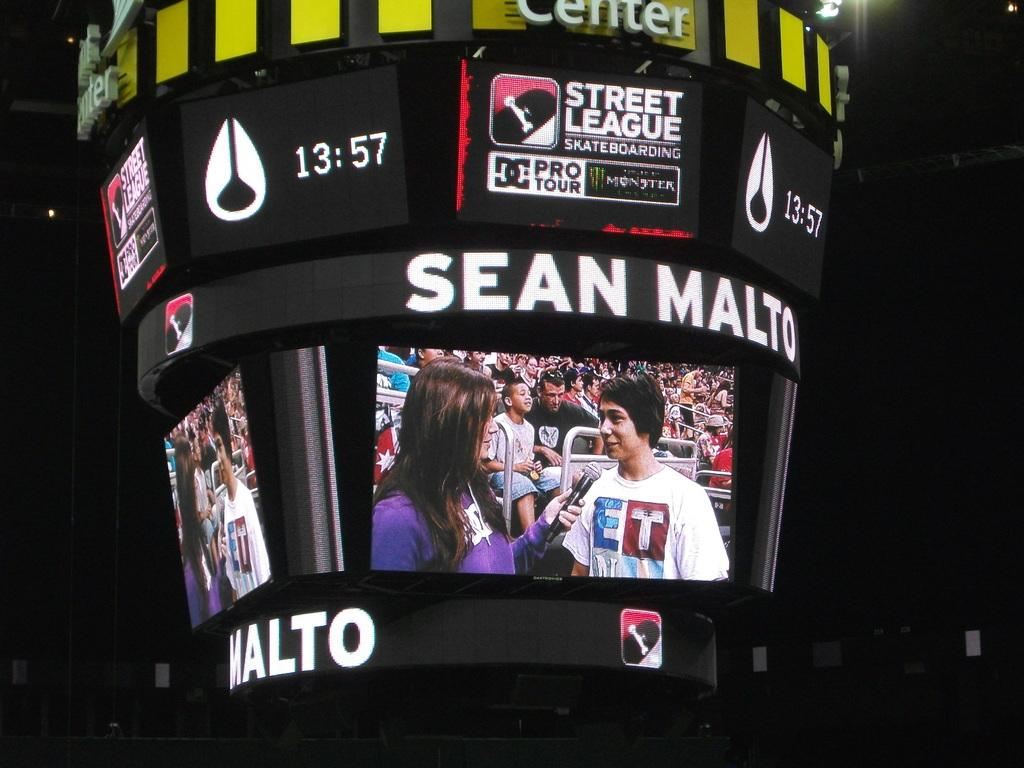Provide a one-sentence caption for the provided image. Scoreboard showing a sports announcer interviewing someone with the name Sean Malto. 